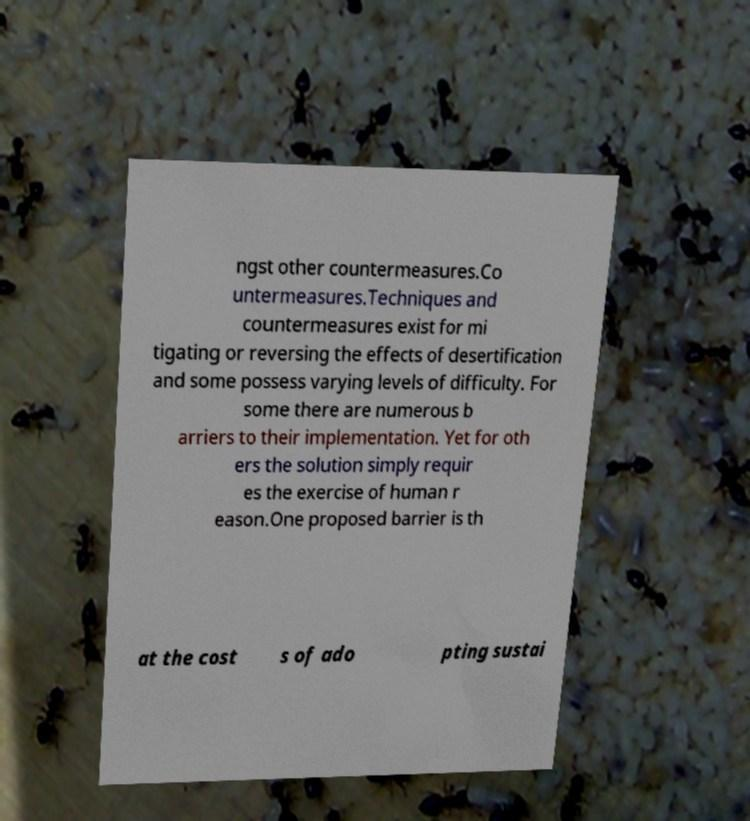Please identify and transcribe the text found in this image. ngst other countermeasures.Co untermeasures.Techniques and countermeasures exist for mi tigating or reversing the effects of desertification and some possess varying levels of difficulty. For some there are numerous b arriers to their implementation. Yet for oth ers the solution simply requir es the exercise of human r eason.One proposed barrier is th at the cost s of ado pting sustai 